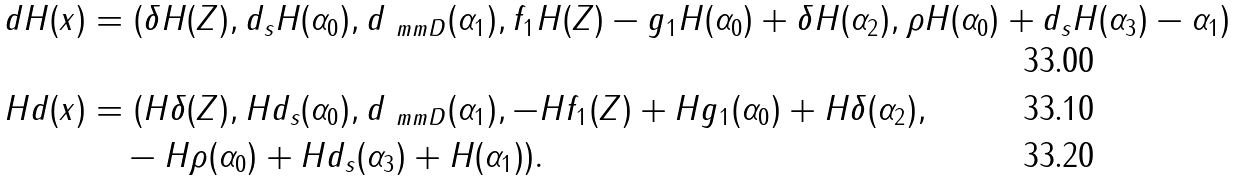<formula> <loc_0><loc_0><loc_500><loc_500>d H ( x ) & = ( \delta H ( Z ) , d _ { s } H ( \alpha _ { 0 } ) , d _ { \ m m D } ( \alpha _ { 1 } ) , f _ { 1 } H ( Z ) - g _ { 1 } H ( \alpha _ { 0 } ) + \delta H ( \alpha _ { 2 } ) , \rho H ( \alpha _ { 0 } ) + d _ { s } H ( \alpha _ { 3 } ) - \alpha _ { 1 } ) \\ H d ( x ) & = ( H \delta ( Z ) , H d _ { s } ( \alpha _ { 0 } ) , d _ { \ m m D } ( \alpha _ { 1 } ) , - H f _ { 1 } ( Z ) + H g _ { 1 } ( \alpha _ { 0 } ) + H \delta ( \alpha _ { 2 } ) , \\ & \quad - H \rho ( \alpha _ { 0 } ) + H d _ { s } ( \alpha _ { 3 } ) + H ( \alpha _ { 1 } ) ) .</formula> 